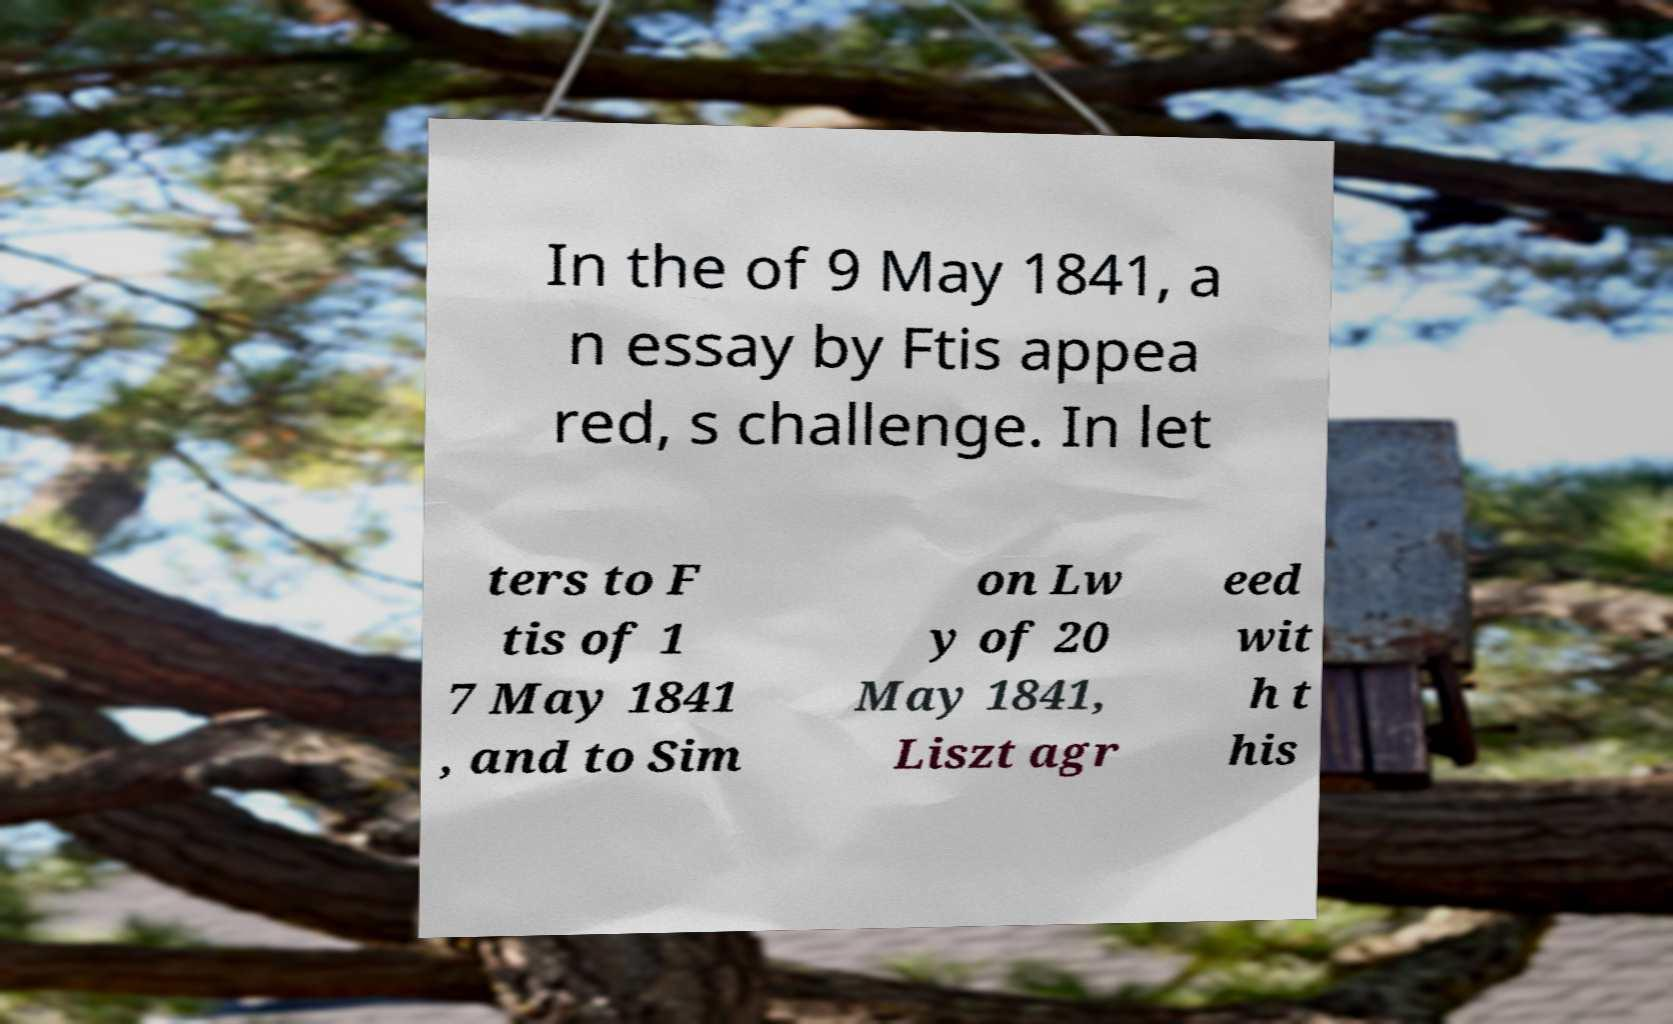For documentation purposes, I need the text within this image transcribed. Could you provide that? In the of 9 May 1841, a n essay by Ftis appea red, s challenge. In let ters to F tis of 1 7 May 1841 , and to Sim on Lw y of 20 May 1841, Liszt agr eed wit h t his 